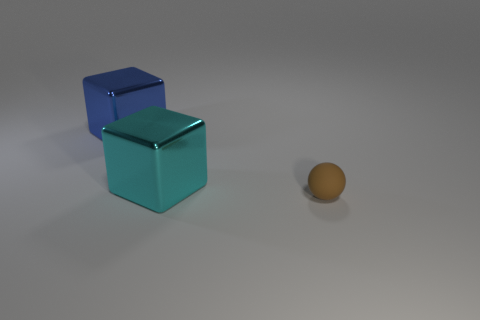Is there anything else that is the same material as the brown sphere?
Provide a succinct answer. No. Is there any other thing that is the same size as the brown object?
Give a very brief answer. No. There is a block to the left of the large cyan object; is there a blue cube in front of it?
Make the answer very short. No. Are there fewer cyan things on the right side of the matte sphere than big cyan metallic blocks in front of the cyan thing?
Ensure brevity in your answer.  No. Do the thing to the left of the cyan object and the large block to the right of the blue metallic block have the same material?
Your response must be concise. Yes. How many large things are either cyan cubes or metal cubes?
Your answer should be compact. 2. Is the number of metal blocks that are to the right of the blue block less than the number of large blue metallic things?
Give a very brief answer. No. Is the matte thing the same shape as the cyan metallic thing?
Offer a terse response. No. How many rubber things are large green spheres or large blue blocks?
Keep it short and to the point. 0. Is there a blue cube of the same size as the cyan object?
Provide a succinct answer. Yes. 